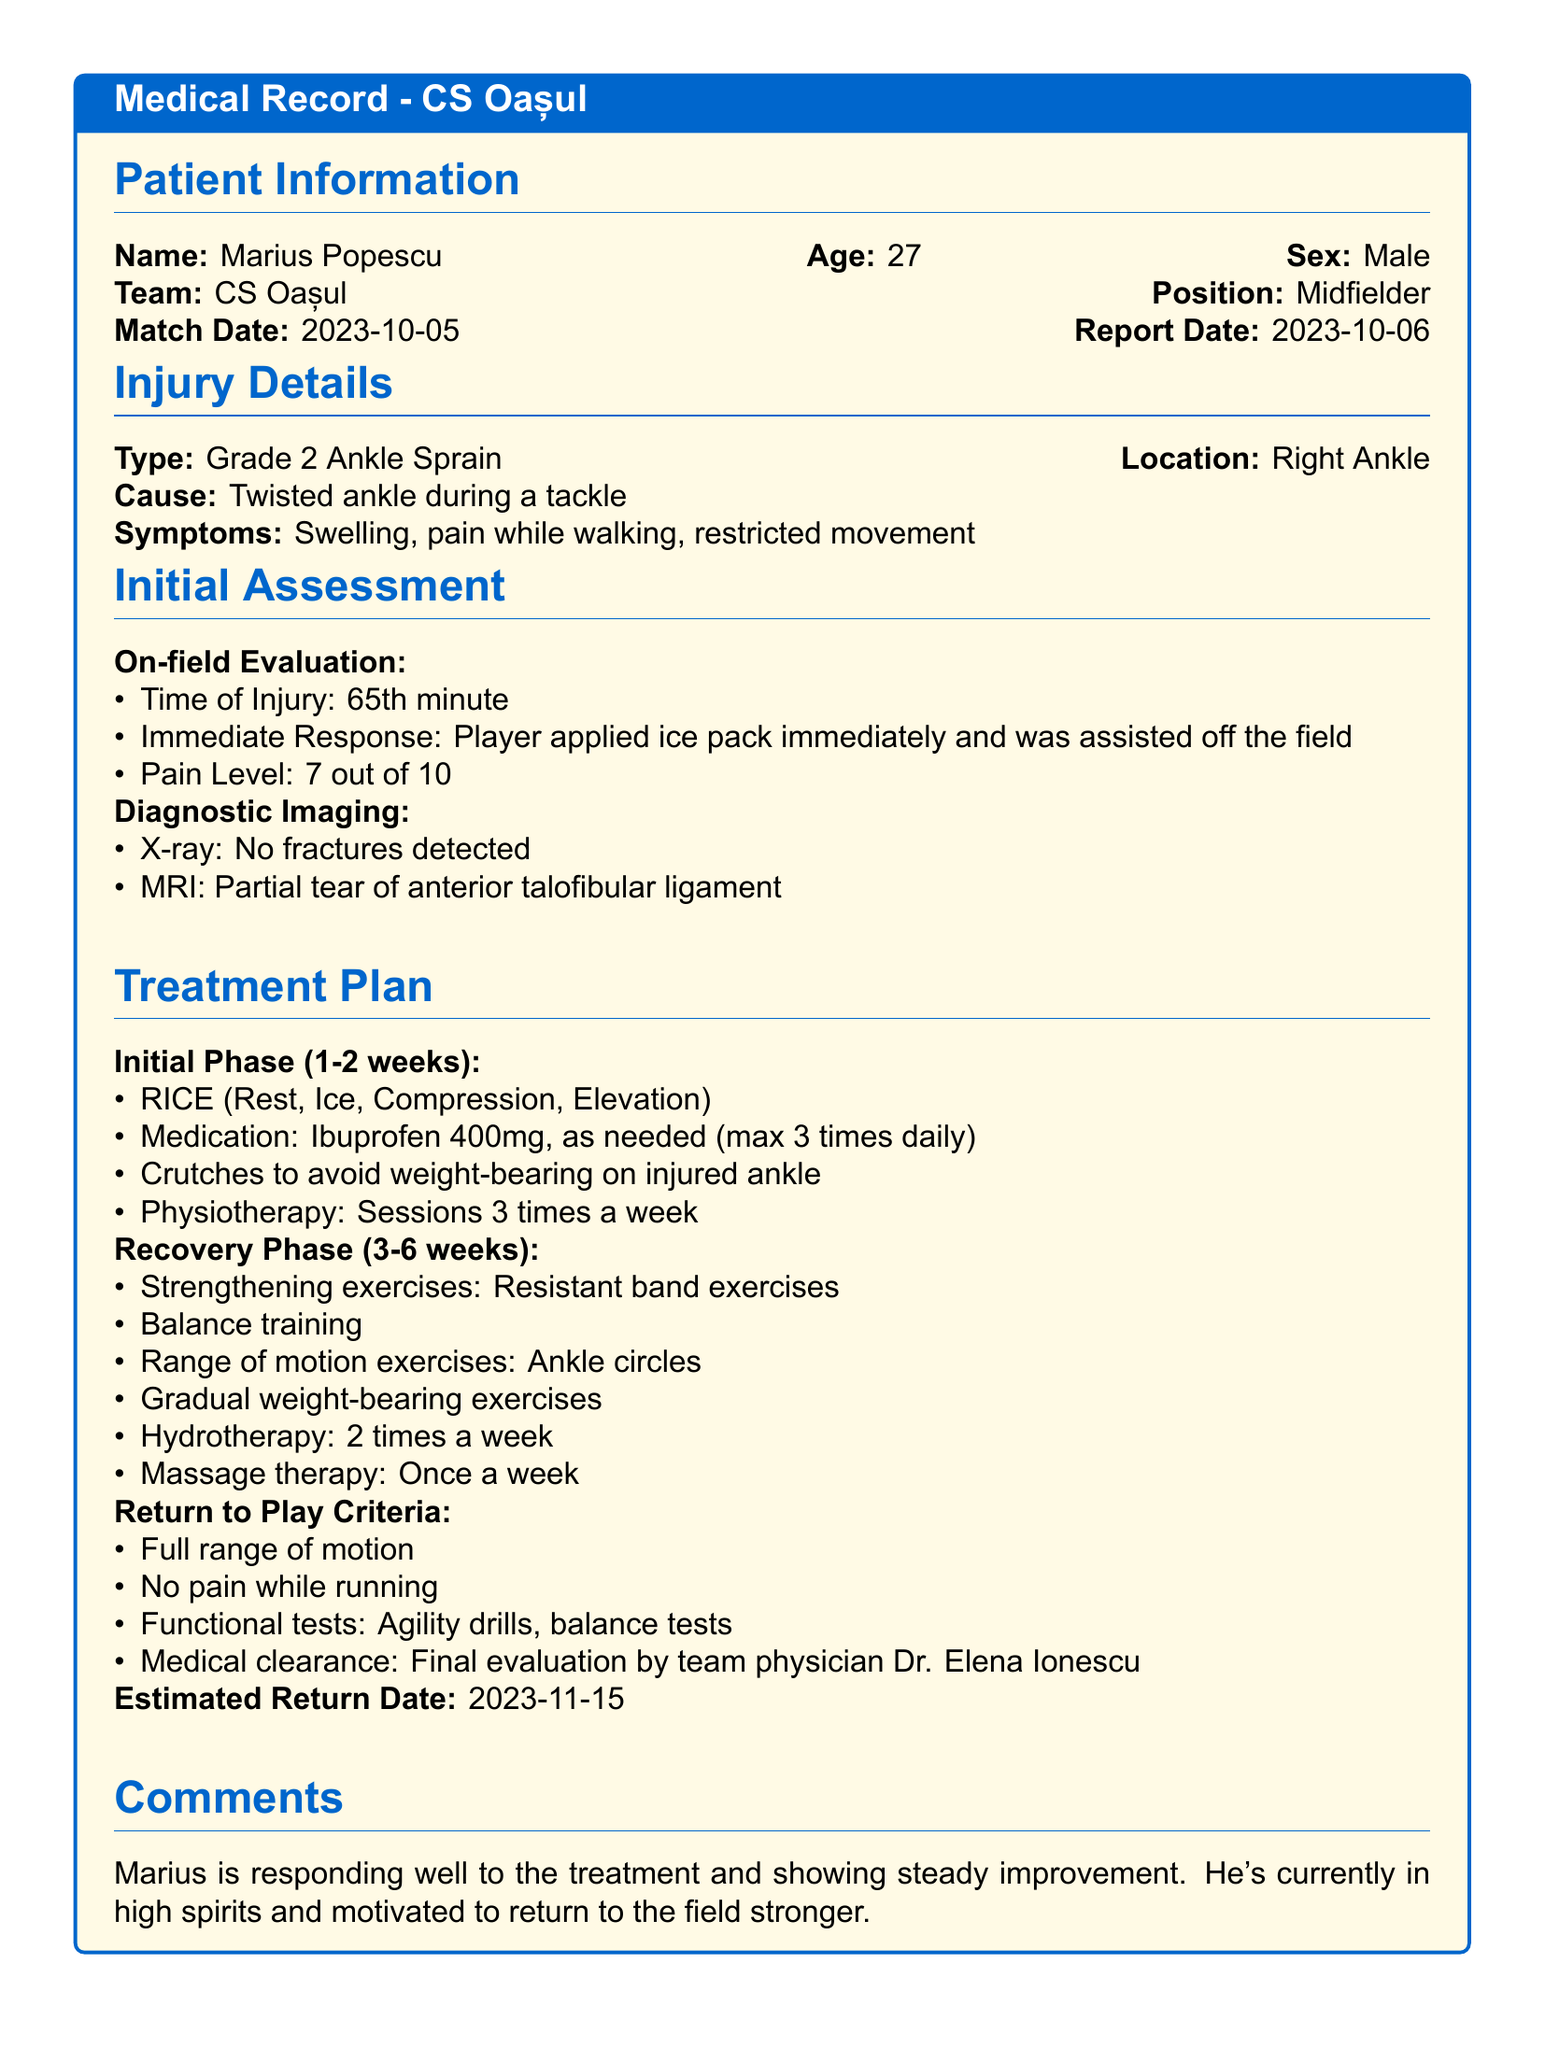What is the patient's name? The patient's name is listed in the Patient Information section as Marius Popescu.
Answer: Marius Popescu What type of injury did the patient sustain? The injury type is specified under Injury Details as Grade 2 Ankle Sprain.
Answer: Grade 2 Ankle Sprain When did the injury occur? The match date indicates when the injury occurred, which is 2023-10-05.
Answer: 2023-10-05 What is the estimated return date for the player? The document states the estimated return date is provided in the Treatment Plan as 2023-11-15.
Answer: 2023-11-15 What was the pain level reported by the patient? The pain level during the on-field evaluation is stated as 7 out of 10.
Answer: 7 out of 10 What treatment method was recommended for the initial phase? The initial treatment plan includes RICE, which stands for Rest, Ice, Compression, and Elevation.
Answer: RICE Who is responsible for the final medical clearance? The final evaluation for medical clearance is to be done by the team physician, Dr. Elena Ionescu.
Answer: Dr. Elena Ionescu How many physiotherapy sessions are scheduled per week initially? The initial treatment plan specifies physiotherapy sessions 3 times a week.
Answer: 3 times a week What imaging technique showed a partial tear? The MRI is indicated in the Diagnostic Imaging section as showing a partial tear.
Answer: MRI 